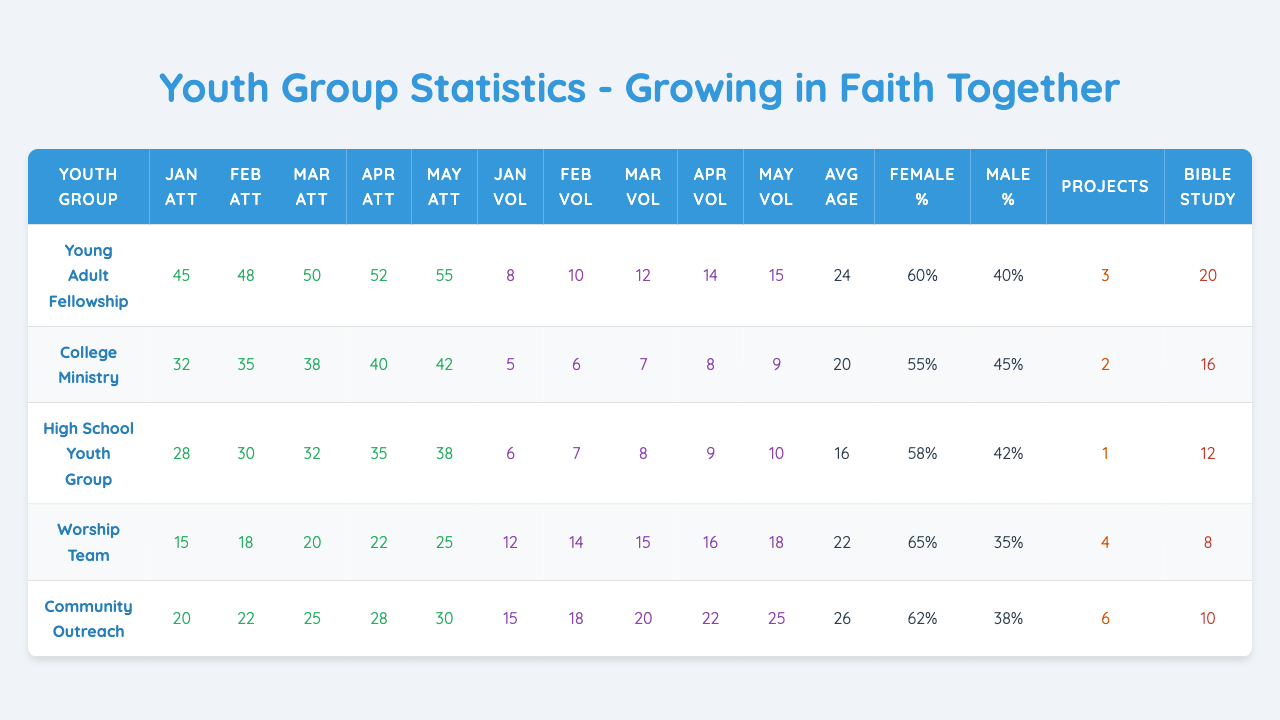What was the attendance for the Worship Team in March? The table shows the "March Attendance" column, and under "Worship Team," the value is 20.
Answer: 20 Which youth group had the highest average attendance in May? The "May Attendance" column shows the following values: Young Adult Fellowship 55, College Ministry 42, High School Youth Group 38, Worship Team 25, and Community Outreach 30. The highest is 55 from the Young Adult Fellowship.
Answer: Young Adult Fellowship How many volunteers participated in College Ministry in April? Referring to the "April Volunteers" column, the value for College Ministry is 8.
Answer: 8 What is the total number of service projects completed across all youth groups? The values for service projects completed are: 3, 2, 1, 4, and 6. Adding them gives 3+2+1+4+6 = 16.
Answer: 16 How many youth groups had an average age of participants above 24? The "Average Age" column shows 24, 20, 16, 22, and 26. Only one group, Community Outreach, has an average age above 24, which is 26.
Answer: One group True or False: The percentage of female participants in the High School Youth Group is greater than that of male participants. Under the "Female Participants (%)" for High School Youth Group, the value is 58%, and the "Male Participants (%)" is 42%, which confirms the statement is true.
Answer: True What is the difference in attendance numbers between the Young Adult Fellowship in January and March? The "January Attendance" for Young Adult Fellowship is 45, and for March, it is 50. The difference is 50 - 45 = 5.
Answer: 5 If we consider the total attendance from January to May for Community Outreach, what is it? The attendance for Community Outreach are: 20 (Jan), 22 (Feb), 25 (Mar), 28 (Apr), and 30 (May). Adding those gives 20 + 22 + 25 + 28 + 30 = 125.
Answer: 125 Which month had the highest number of volunteers for the High School Youth Group? Looking at the "Volunteers" columns for High School Youth Group: 6 (Jan), 7 (Feb), 8 (Mar), 9 (Apr), and 10 (May). The highest is in May with 10 volunteers.
Answer: May How many more volunteers did the Worship Team have in April compared to January? The volunteers in January for Worship Team are 12 and in April they are 16. The difference is 16 - 12 = 4.
Answer: 4 